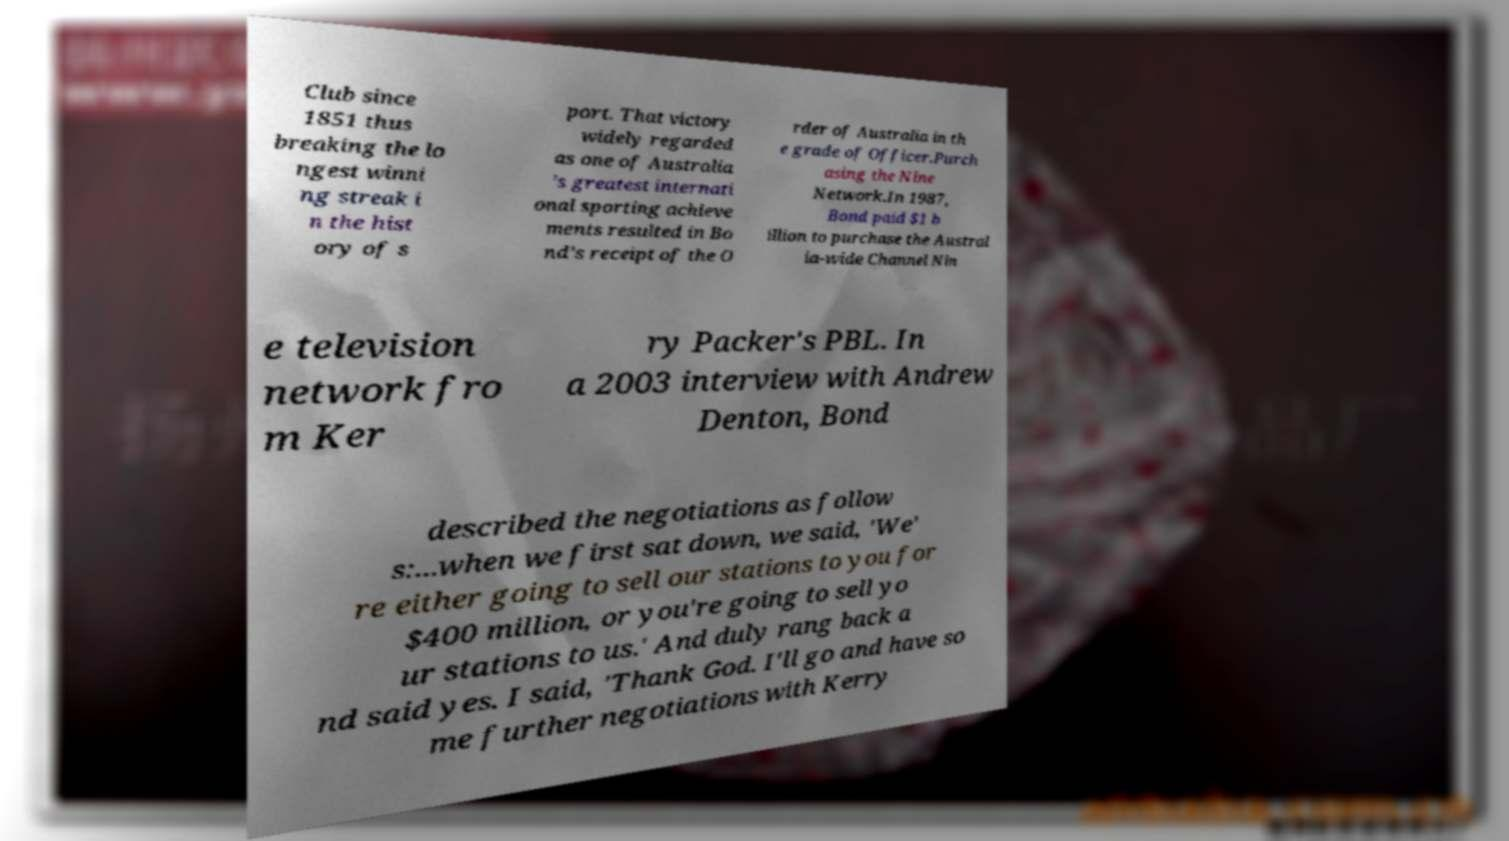Please identify and transcribe the text found in this image. Club since 1851 thus breaking the lo ngest winni ng streak i n the hist ory of s port. That victory widely regarded as one of Australia ’s greatest internati onal sporting achieve ments resulted in Bo nd’s receipt of the O rder of Australia in th e grade of Officer.Purch asing the Nine Network.In 1987, Bond paid $1 b illion to purchase the Austral ia-wide Channel Nin e television network fro m Ker ry Packer's PBL. In a 2003 interview with Andrew Denton, Bond described the negotiations as follow s:...when we first sat down, we said, 'We' re either going to sell our stations to you for $400 million, or you're going to sell yo ur stations to us.' And duly rang back a nd said yes. I said, 'Thank God. I'll go and have so me further negotiations with Kerry 